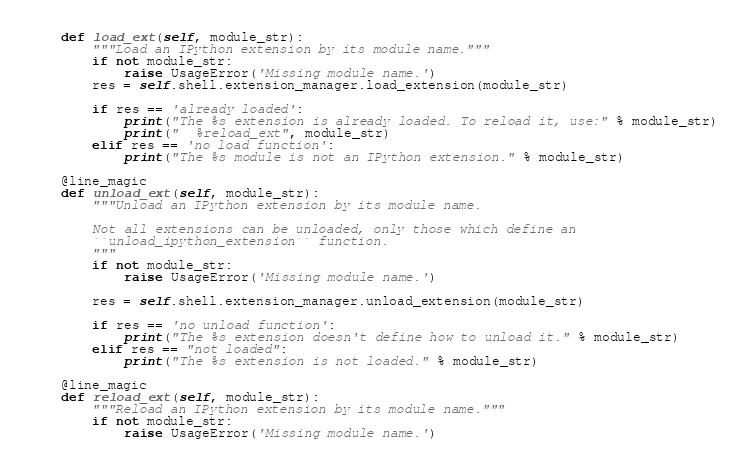Convert code to text. <code><loc_0><loc_0><loc_500><loc_500><_Python_>    def load_ext(self, module_str):
        """Load an IPython extension by its module name."""
        if not module_str:
            raise UsageError('Missing module name.')
        res = self.shell.extension_manager.load_extension(module_str)
        
        if res == 'already loaded':
            print("The %s extension is already loaded. To reload it, use:" % module_str)
            print("  %reload_ext", module_str)
        elif res == 'no load function':
            print("The %s module is not an IPython extension." % module_str)

    @line_magic
    def unload_ext(self, module_str):
        """Unload an IPython extension by its module name.
        
        Not all extensions can be unloaded, only those which define an
        ``unload_ipython_extension`` function.
        """
        if not module_str:
            raise UsageError('Missing module name.')
        
        res = self.shell.extension_manager.unload_extension(module_str)
        
        if res == 'no unload function':
            print("The %s extension doesn't define how to unload it." % module_str)
        elif res == "not loaded":
            print("The %s extension is not loaded." % module_str)

    @line_magic
    def reload_ext(self, module_str):
        """Reload an IPython extension by its module name."""
        if not module_str:
            raise UsageError('Missing module name.')</code> 